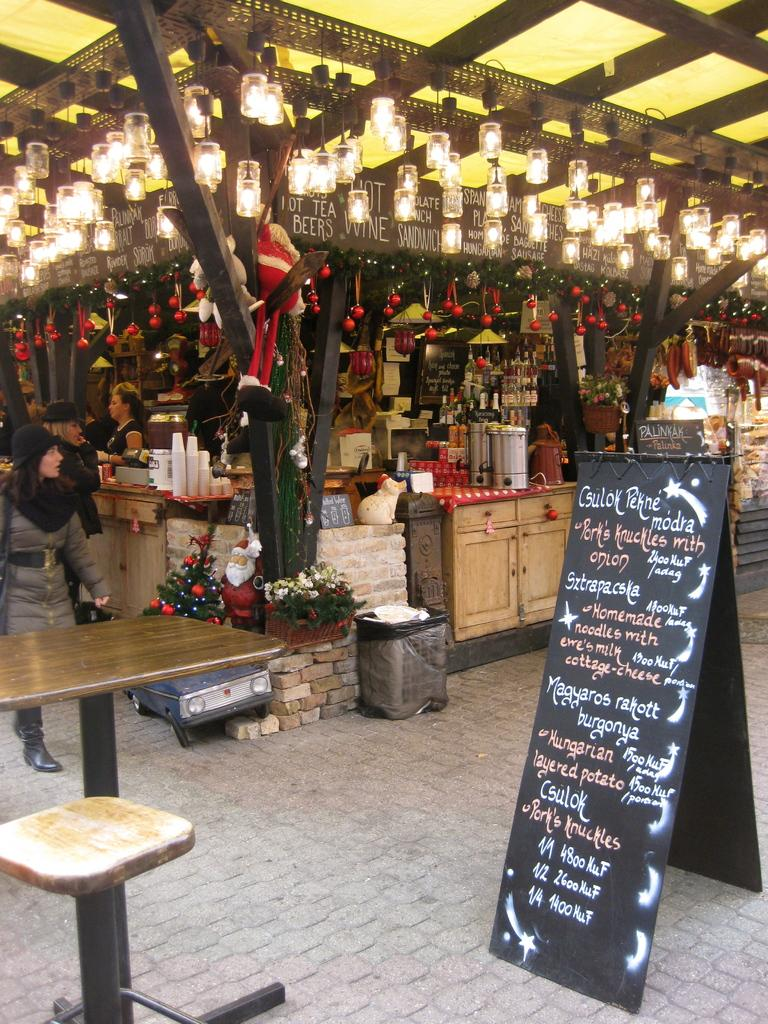What can be seen in the image? There are people standing in the image, and there is a market in the image. What might be used for displaying information or prices in the market? There is a blackboard with writing on it in the image. What type of stove is being used by the people in the image? There is no stove present in the image; it features people standing in a market with a blackboard. 